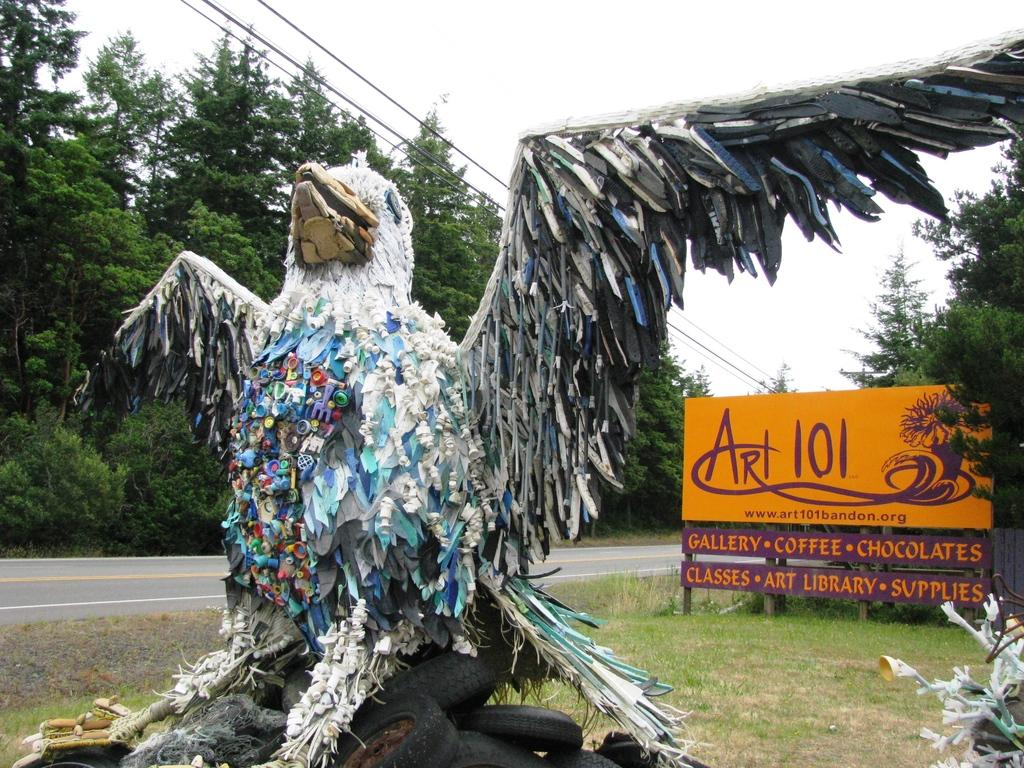What animal is the main subject of the image? There is an eagle in the image. What is the environment like around the eagle? The eagle is surrounded by waste items. What can be seen in the background of the image? There is a road, a board with text, and trees in the background of the image. How many feet are visible on the turkey in the image? There is no turkey present in the image; it features an eagle. What type of basket is being used by the eagle in the image? There is no basket present in the image; the eagle is surrounded by waste items. 